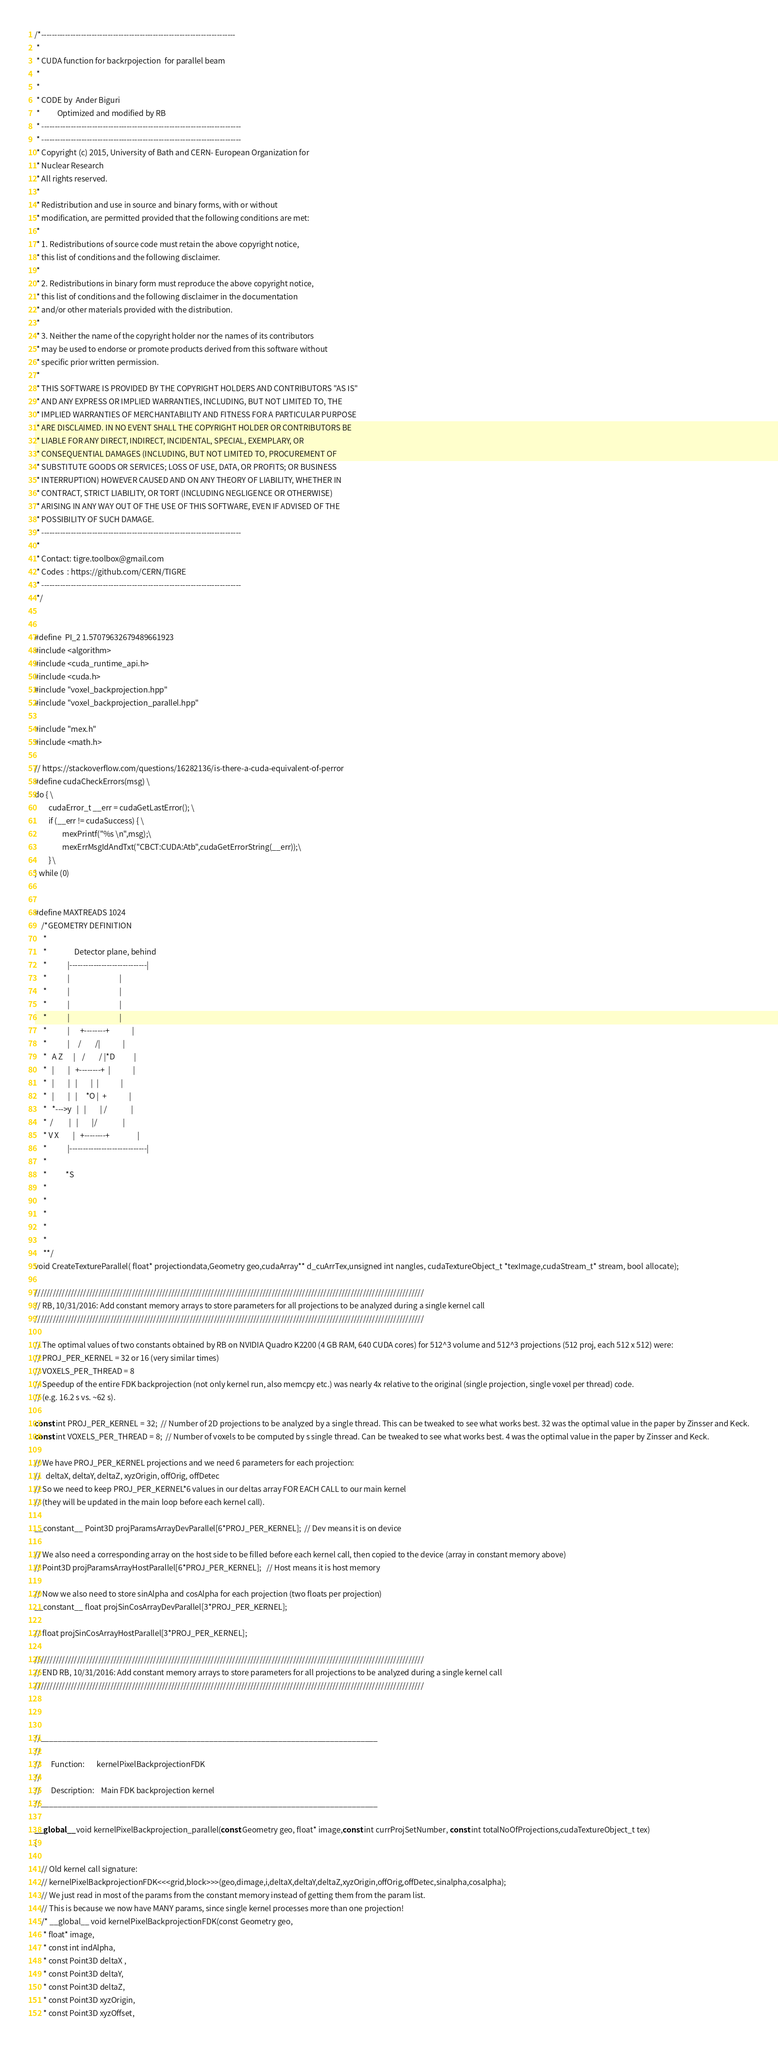<code> <loc_0><loc_0><loc_500><loc_500><_Cuda_>/*-------------------------------------------------------------------------
 *
 * CUDA function for backrpojection  for parallel beam
 *
 *
 * CODE by  Ander Biguri
 *          Optimized and modified by RB
 * ---------------------------------------------------------------------------
 * ---------------------------------------------------------------------------
 * Copyright (c) 2015, University of Bath and CERN- European Organization for
 * Nuclear Research
 * All rights reserved.
 *
 * Redistribution and use in source and binary forms, with or without
 * modification, are permitted provided that the following conditions are met:
 *
 * 1. Redistributions of source code must retain the above copyright notice,
 * this list of conditions and the following disclaimer.
 *
 * 2. Redistributions in binary form must reproduce the above copyright notice,
 * this list of conditions and the following disclaimer in the documentation
 * and/or other materials provided with the distribution.
 *
 * 3. Neither the name of the copyright holder nor the names of its contributors
 * may be used to endorse or promote products derived from this software without
 * specific prior written permission.
 *
 * THIS SOFTWARE IS PROVIDED BY THE COPYRIGHT HOLDERS AND CONTRIBUTORS "AS IS"
 * AND ANY EXPRESS OR IMPLIED WARRANTIES, INCLUDING, BUT NOT LIMITED TO, THE
 * IMPLIED WARRANTIES OF MERCHANTABILITY AND FITNESS FOR A PARTICULAR PURPOSE
 * ARE DISCLAIMED. IN NO EVENT SHALL THE COPYRIGHT HOLDER OR CONTRIBUTORS BE
 * LIABLE FOR ANY DIRECT, INDIRECT, INCIDENTAL, SPECIAL, EXEMPLARY, OR
 * CONSEQUENTIAL DAMAGES (INCLUDING, BUT NOT LIMITED TO, PROCUREMENT OF
 * SUBSTITUTE GOODS OR SERVICES; LOSS OF USE, DATA, OR PROFITS; OR BUSINESS
 * INTERRUPTION) HOWEVER CAUSED AND ON ANY THEORY OF LIABILITY, WHETHER IN
 * CONTRACT, STRICT LIABILITY, OR TORT (INCLUDING NEGLIGENCE OR OTHERWISE)
 * ARISING IN ANY WAY OUT OF THE USE OF THIS SOFTWARE, EVEN IF ADVISED OF THE
 * POSSIBILITY OF SUCH DAMAGE.
 * ---------------------------------------------------------------------------
 *
 * Contact: tigre.toolbox@gmail.com
 * Codes  : https://github.com/CERN/TIGRE
 * ---------------------------------------------------------------------------
 */


#define  PI_2 1.57079632679489661923
#include <algorithm>
#include <cuda_runtime_api.h>
#include <cuda.h>
#include "voxel_backprojection.hpp"
#include "voxel_backprojection_parallel.hpp"

#include "mex.h"
#include <math.h>

// https://stackoverflow.com/questions/16282136/is-there-a-cuda-equivalent-of-perror
#define cudaCheckErrors(msg) \
do { \
        cudaError_t __err = cudaGetLastError(); \
        if (__err != cudaSuccess) { \
                mexPrintf("%s \n",msg);\
                mexErrMsgIdAndTxt("CBCT:CUDA:Atb",cudaGetErrorString(__err));\
        } \
} while (0)
    
    
#define MAXTREADS 1024
    /*GEOMETRY DEFINITION
     *
     *                Detector plane, behind
     *            |-----------------------------|
     *            |                             |
     *            |                             |
     *            |                             |
     *            |                             |
     *            |      +--------+             |
     *            |     /        /|             |
     *   A Z      |    /        / |*D           |
     *   |        |   +--------+  |             |
     *   |        |   |        |  |             |
     *   |        |   |     *O |  +             |
     *   *--->y   |   |        | /              |
     *  /         |   |        |/               |
     * V X        |   +--------+                |
     *            |-----------------------------|
     *
     *           *S
     *
     *
     *
     *
     *
     **/
void CreateTextureParallel( float* projectiondata,Geometry geo,cudaArray** d_cuArrTex,unsigned int nangles, cudaTextureObject_t *texImage,cudaStream_t* stream, bool allocate);

////////////////////////////////////////////////////////////////////////////////////////////////////////////////////////////////
// RB, 10/31/2016: Add constant memory arrays to store parameters for all projections to be analyzed during a single kernel call
////////////////////////////////////////////////////////////////////////////////////////////////////////////////////////////////

// The optimal values of two constants obtained by RB on NVIDIA Quadro K2200 (4 GB RAM, 640 CUDA cores) for 512^3 volume and 512^3 projections (512 proj, each 512 x 512) were:
// PROJ_PER_KERNEL = 32 or 16 (very similar times)
// VOXELS_PER_THREAD = 8
// Speedup of the entire FDK backprojection (not only kernel run, also memcpy etc.) was nearly 4x relative to the original (single projection, single voxel per thread) code.
// (e.g. 16.2 s vs. ~62 s).

const int PROJ_PER_KERNEL = 32;  // Number of 2D projections to be analyzed by a single thread. This can be tweaked to see what works best. 32 was the optimal value in the paper by Zinsser and Keck.
const int VOXELS_PER_THREAD = 8;  // Number of voxels to be computed by s single thread. Can be tweaked to see what works best. 4 was the optimal value in the paper by Zinsser and Keck.

// We have PROJ_PER_KERNEL projections and we need 6 parameters for each projection:
//   deltaX, deltaY, deltaZ, xyzOrigin, offOrig, offDetec
// So we need to keep PROJ_PER_KERNEL*6 values in our deltas array FOR EACH CALL to our main kernel
// (they will be updated in the main loop before each kernel call).

__constant__ Point3D projParamsArrayDevParallel[6*PROJ_PER_KERNEL];  // Dev means it is on device

// We also need a corresponding array on the host side to be filled before each kernel call, then copied to the device (array in constant memory above)
// Point3D projParamsArrayHostParallel[6*PROJ_PER_KERNEL];   // Host means it is host memory

// Now we also need to store sinAlpha and cosAlpha for each projection (two floats per projection)
__constant__ float projSinCosArrayDevParallel[3*PROJ_PER_KERNEL];

// float projSinCosArrayHostParallel[3*PROJ_PER_KERNEL];

////////////////////////////////////////////////////////////////////////////////////////////////////////////////////////////////
// END RB, 10/31/2016: Add constant memory arrays to store parameters for all projections to be analyzed during a single kernel call
////////////////////////////////////////////////////////////////////////////////////////////////////////////////////////////////



//______________________________________________________________________________
//
//      Function:       kernelPixelBackprojectionFDK
//
//      Description:    Main FDK backprojection kernel
//______________________________________________________________________________

__global__ void kernelPixelBackprojection_parallel(const Geometry geo, float* image,const int currProjSetNumber, const int totalNoOfProjections,cudaTextureObject_t tex)
{
    
    // Old kernel call signature:
    // kernelPixelBackprojectionFDK<<<grid,block>>>(geo,dimage,i,deltaX,deltaY,deltaZ,xyzOrigin,offOrig,offDetec,sinalpha,cosalpha);
    // We just read in most of the params from the constant memory instead of getting them from the param list.
    // This is because we now have MANY params, since single kernel processes more than one projection!
    /* __global__ void kernelPixelBackprojectionFDK(const Geometry geo,
     * float* image,
     * const int indAlpha,
     * const Point3D deltaX ,
     * const Point3D deltaY,
     * const Point3D deltaZ,
     * const Point3D xyzOrigin,
     * const Point3D xyzOffset,</code> 